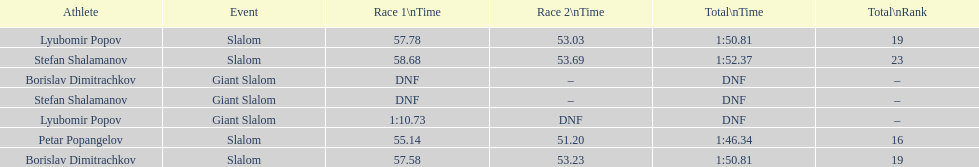Which athletes had consecutive times under 58 for both races? Lyubomir Popov, Borislav Dimitrachkov, Petar Popangelov. 